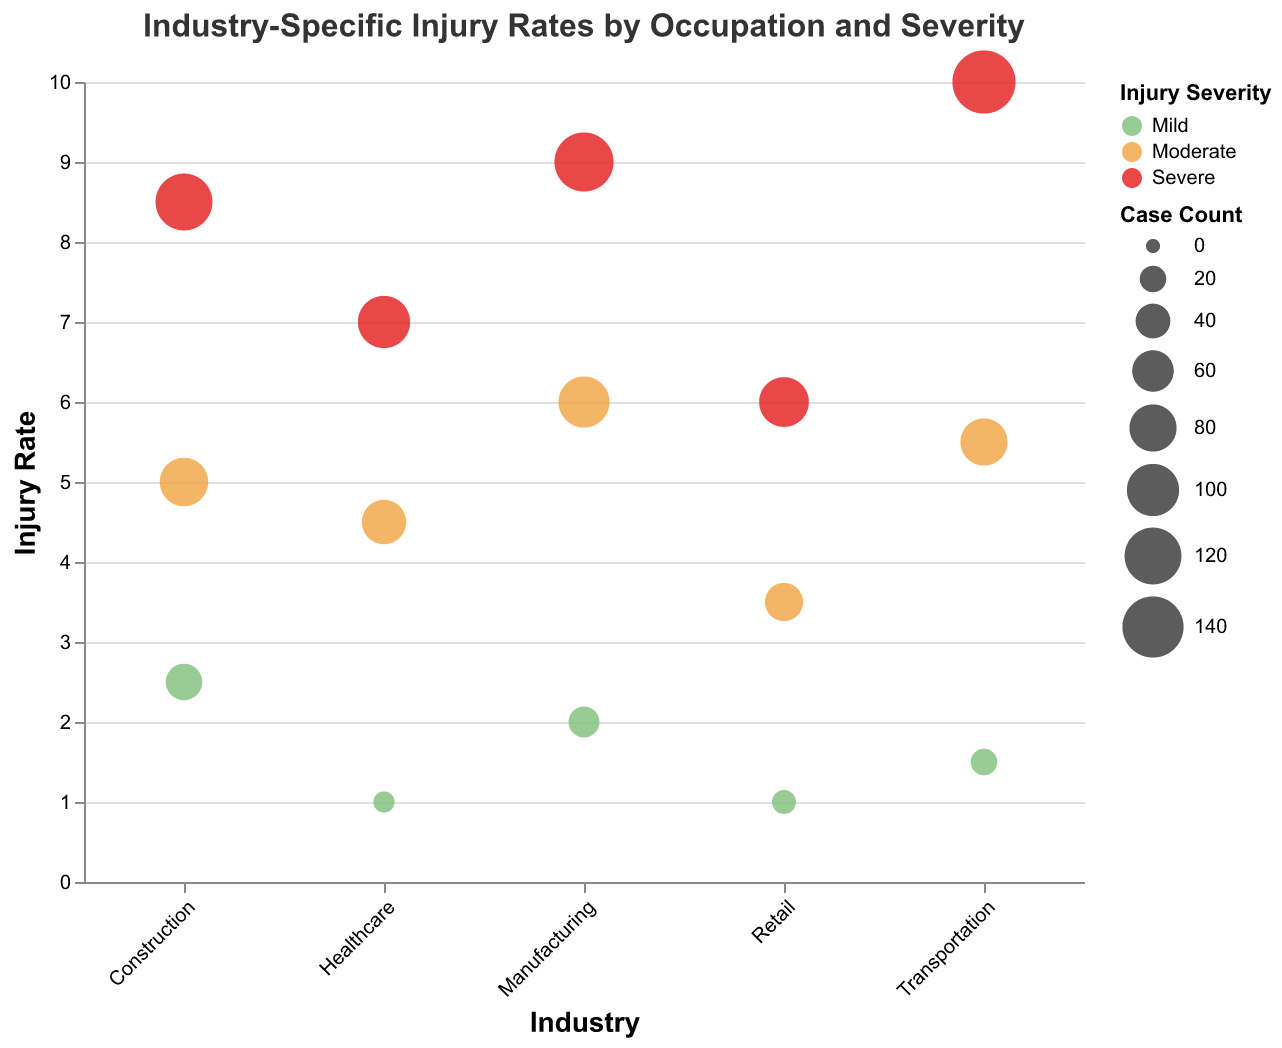What is the title of the chart? The title is displayed at the top of the chart. It reads "Industry-Specific Injury Rates by Occupation and Severity"
Answer: Industry-Specific Injury Rates by Occupation and Severity Which industry has the highest injury rate? To determine the highest injury rate, look at the y-axis values and find the data point with the maximum value. The data point with an injury rate of 10.0 belongs to the Truck Drivers in the Transportation industry.
Answer: Transportation What is the injury rate for Nursing Assistants? Locate the Healthcare industry and find the bubble representing Nursing Assistants. The tooltip or vertical position of the bubble indicates an injury rate of 4.5.
Answer: 4.5 Which occupation type in the Manufacturing industry has the highest case count? Examine the bubbles within the Manufacturing industry, comparing sizes to find the largest one. The Machine Operators have the largest bubble, representing the highest case count of 130.
Answer: Machine Operators Which occupation type and severity combination has the smallest bubble? The smallest bubble, based on size, is in the Healthcare industry for Hospital Administrators with a mild severity, indicated by the size of 10.
Answer: Hospital Administrators with mild severity What is the total case count for all severe injuries? Add up the case counts for all bubbles colored red (Severe).
Calculation: 120 (Construction Laborers) + 100 (Nurses) + 130 (Machine Operators) + 150 (Truck Drivers) + 90 (Stock Clerks) = 590.
Answer: 590 Compare the injury rate of Sales Associates in Retail versus Delivery Drivers in Transportation. Which is higher? Find the injury rate for both occupation types. Sales Associates have an injury rate of 3.5, while Delivery Drivers have an injury rate of 5.5.
Answer: Delivery Drivers How does the average injury rate of all occupation types in Construction compare to the average in Manufacturing? Calculate the average injury rates for both industries. 
Construction:
(8.5 (Construction Laborers) + 5.0 (Carpenters) + 2.5 (Electricians)) / 3 = 5.33.
Manufacturing:
(6.0 (Assemblers) + 9.0 (Machine Operators) + 2.0 (Line Supervisors)) / 3 = 5.67. 
Manufacturing has a slightly higher average injury rate.
Answer: Manufacturing Which occupation type in the Healthcare industry has the highest injury rate, and what is its severity? Look at the bubbles in the Healthcare industry. The highest injury rate is for Nurses, at a severity of severe with an injury rate of 7.0.
Answer: Nurses, Severe What is the total number of mild severity cases across all industries? Add up the case counts for all mild severity bubbles.
Calculation: 45 (Electricians) + 10 (Hospital Administrators) + 30 (Line Supervisors) + 20 (Logistics Coordinators) + 15 (Managers) = 120.
Answer: 120 